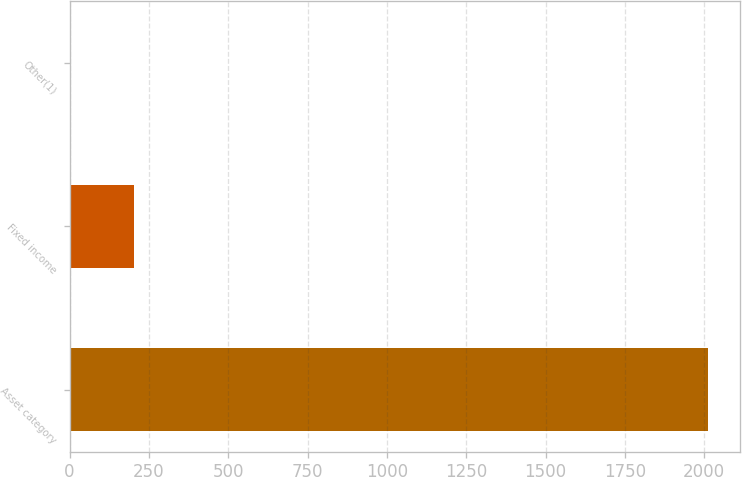Convert chart. <chart><loc_0><loc_0><loc_500><loc_500><bar_chart><fcel>Asset category<fcel>Fixed income<fcel>Other(1)<nl><fcel>2011<fcel>202.68<fcel>1.76<nl></chart> 